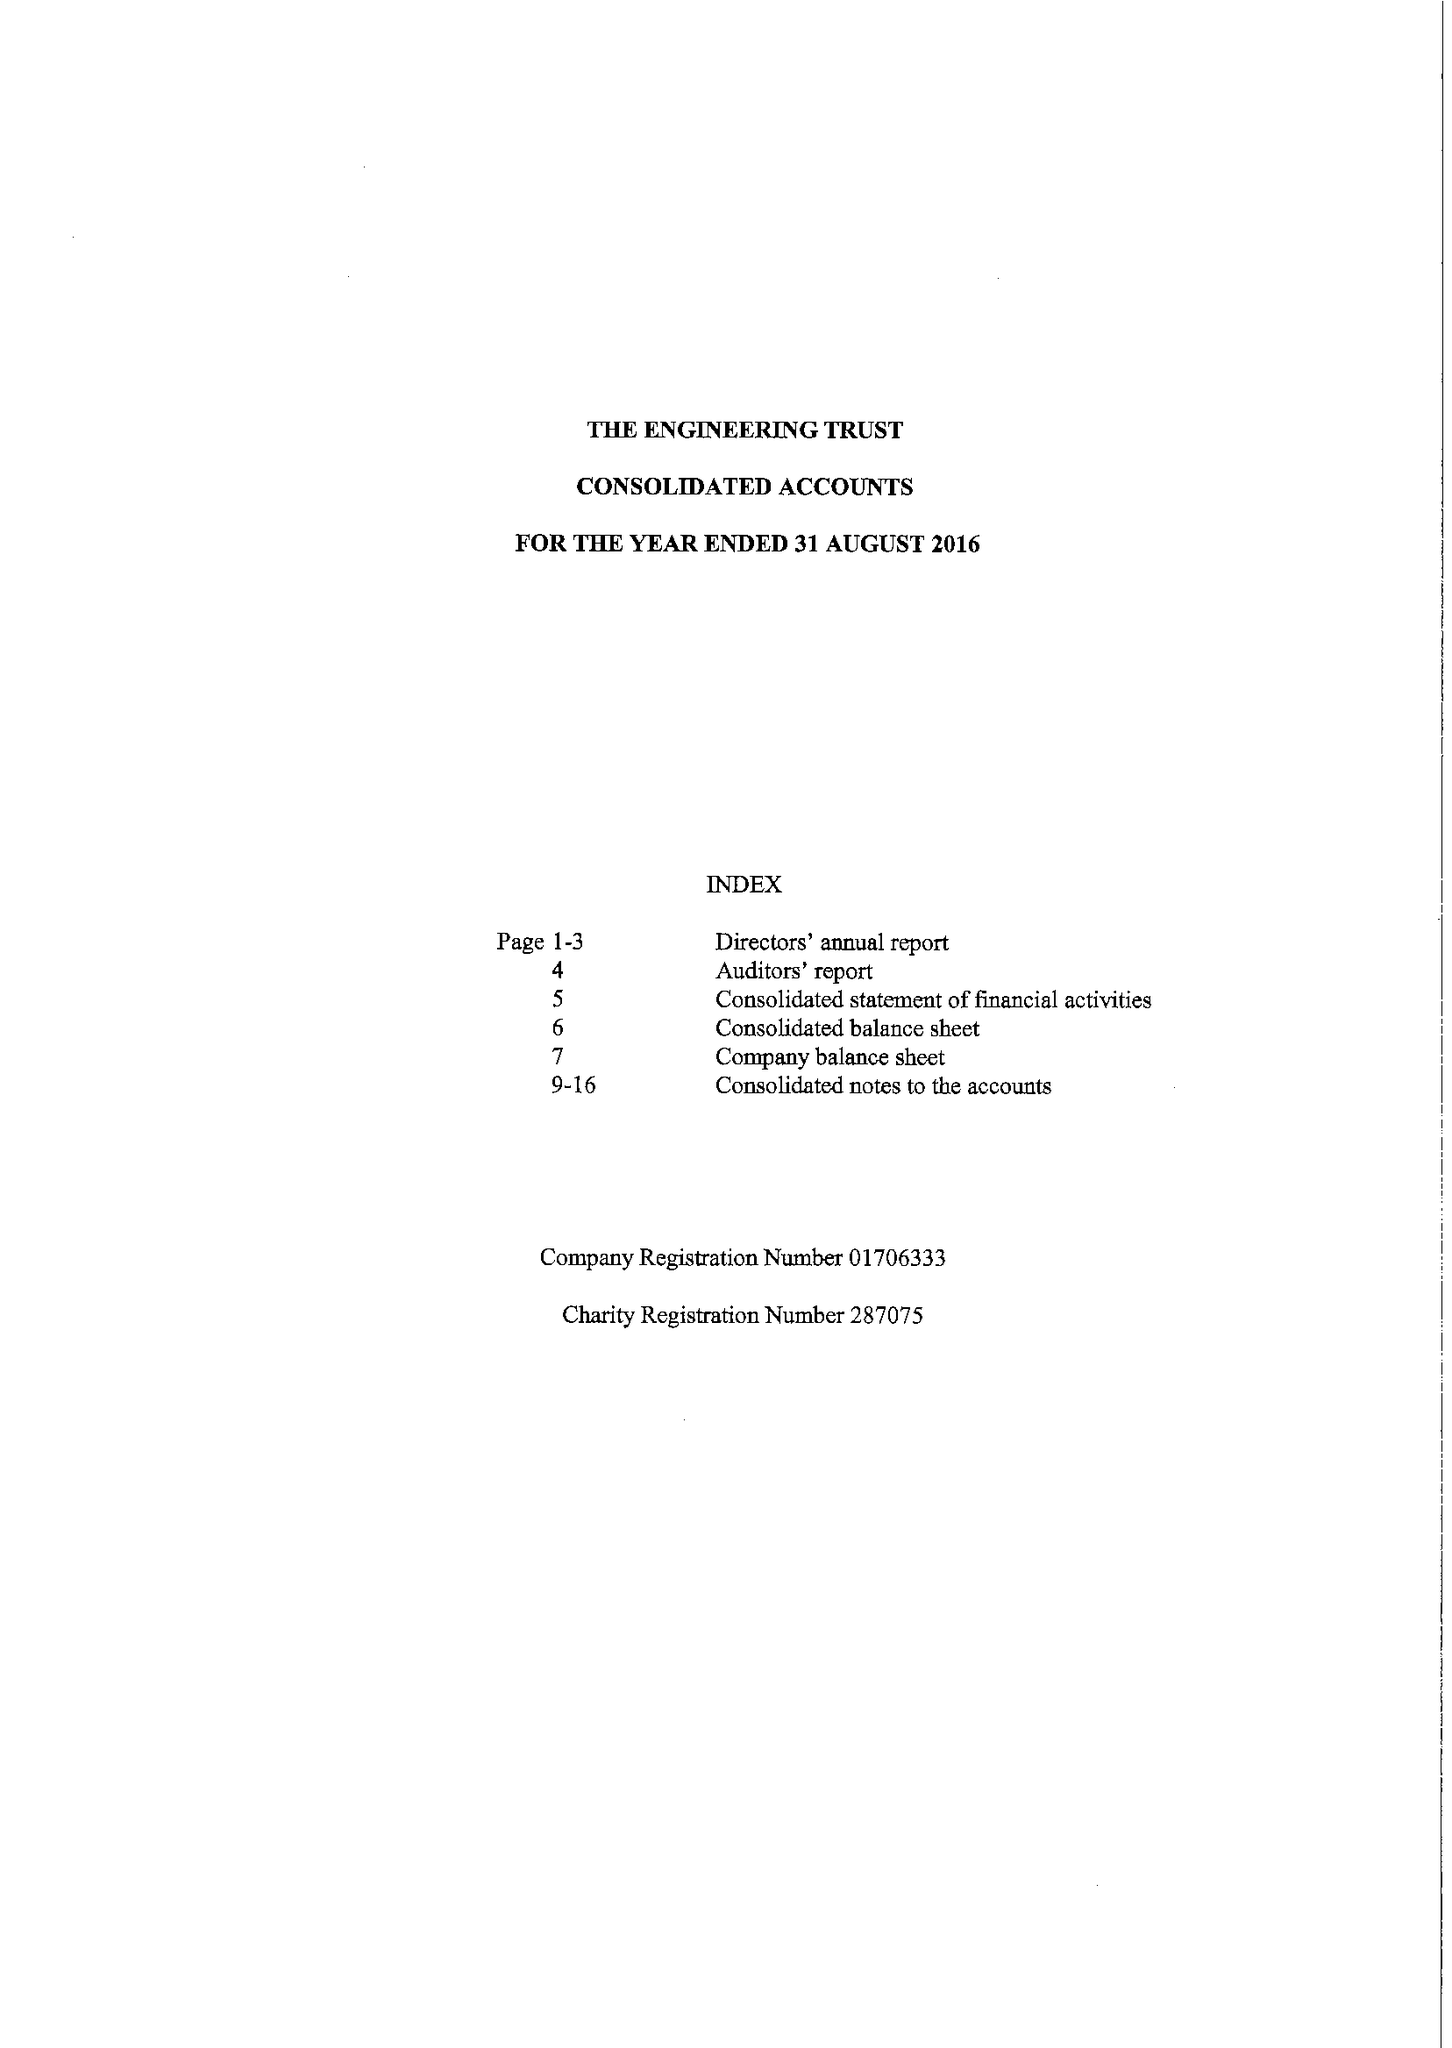What is the value for the spending_annually_in_british_pounds?
Answer the question using a single word or phrase. 70687.00 